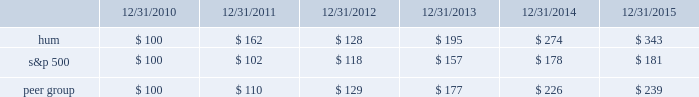Declaration and payment of future quarterly dividends is at the discretion of our board and may be adjusted as business needs or market conditions change .
In addition , under the terms of the merger agreement , we have agreed with aetna to coordinate the declaration and payment of dividends so that our stockholders do not fail to receive a quarterly dividend around the time of the closing of the merger .
On october 29 , 2015 , the board declared a cash dividend of $ 0.29 per share that was paid on january 29 , 2016 to stockholders of record on december 30 , 2015 , for an aggregate amount of $ 43 million .
Stock total return performance the following graph compares our total return to stockholders with the returns of the standard & poor 2019s composite 500 index ( 201cs&p 500 201d ) and the dow jones us select health care providers index ( 201cpeer group 201d ) for the five years ended december 31 , 2015 .
The graph assumes an investment of $ 100 in each of our common stock , the s&p 500 , and the peer group on december 31 , 2010 , and that dividends were reinvested when paid. .
The stock price performance included in this graph is not necessarily indicative of future stock price performance. .
What was the percent of the decline in the stock price performance for hum from 2011 to 2012? 
Computations: ((128 / 162) / 162)
Answer: 0.00488. 